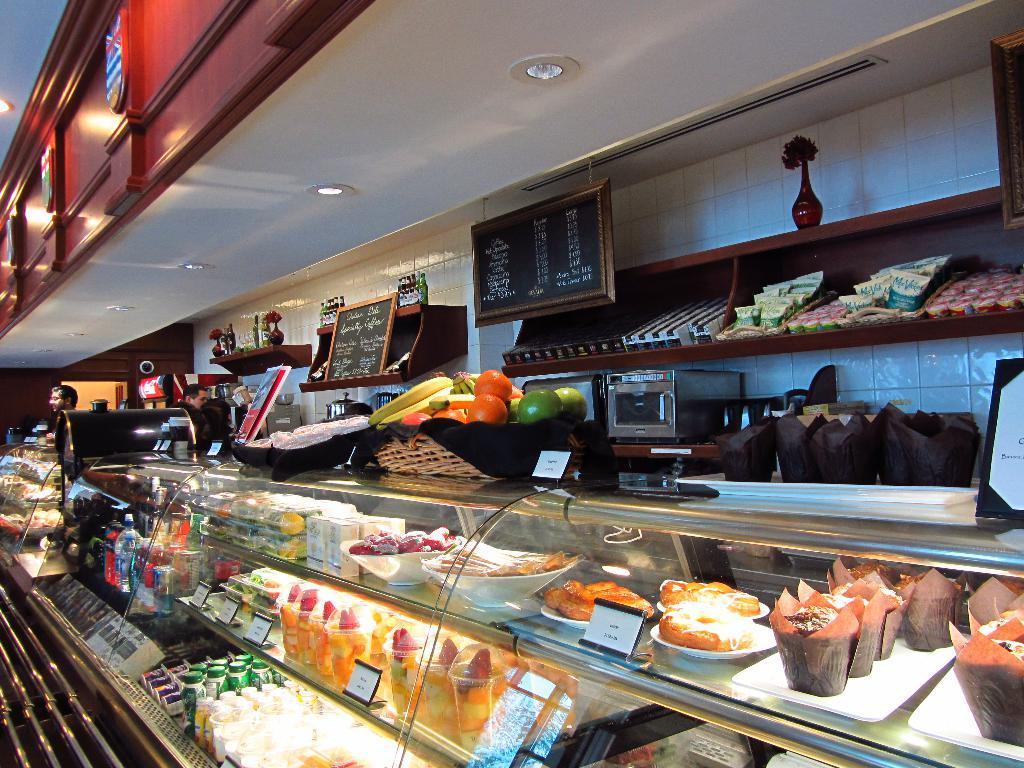Could you give a brief overview of what you see in this image? In this image we can see some food items in the rack, on the rack there are fruits in the basket, there are boards with text written on the board, a board is changed to the ceiling and a board placed on the shelf, there are few objects and flower vase on the shelf and two people standing in the background and lights attached to the ceiling. 